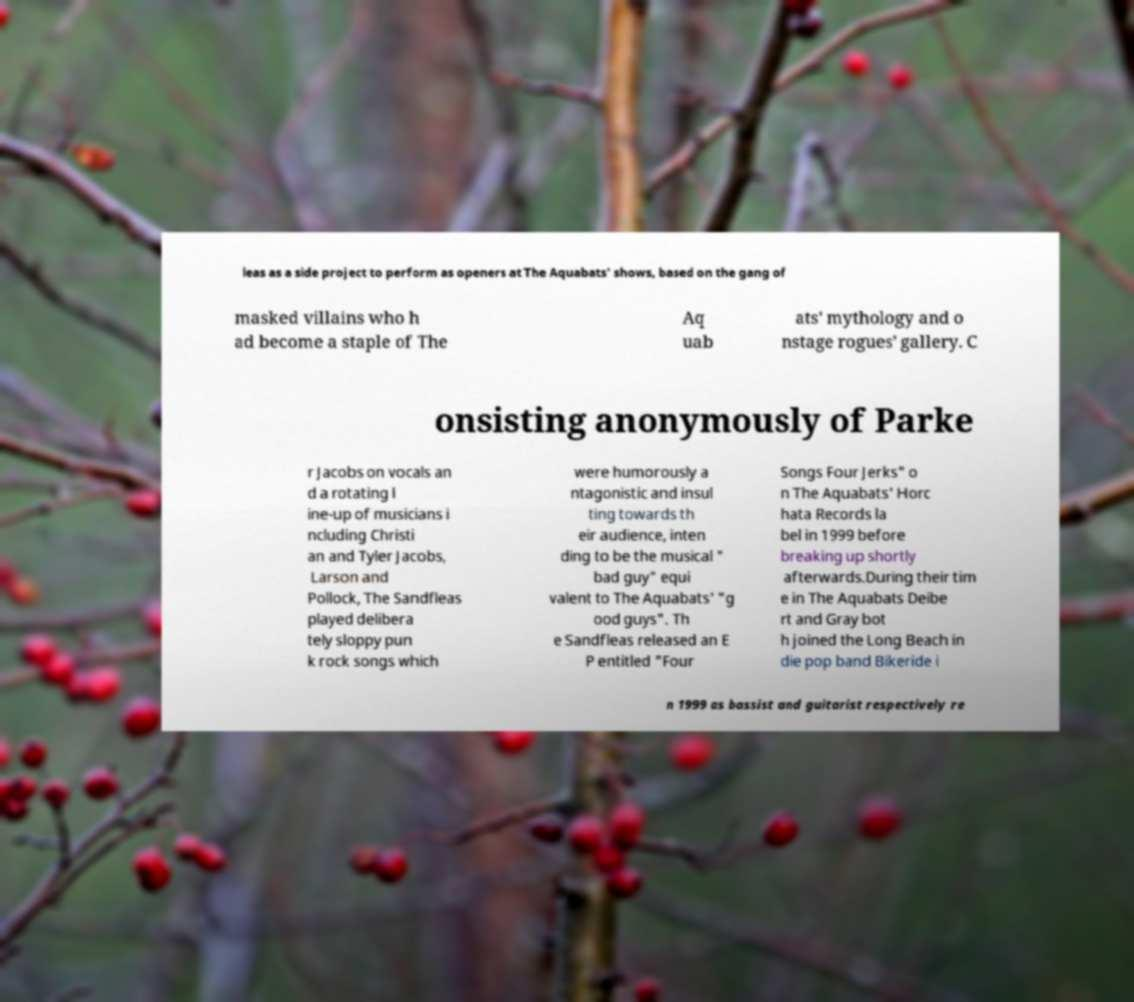For documentation purposes, I need the text within this image transcribed. Could you provide that? leas as a side project to perform as openers at The Aquabats' shows, based on the gang of masked villains who h ad become a staple of The Aq uab ats' mythology and o nstage rogues' gallery. C onsisting anonymously of Parke r Jacobs on vocals an d a rotating l ine-up of musicians i ncluding Christi an and Tyler Jacobs, Larson and Pollock, The Sandfleas played delibera tely sloppy pun k rock songs which were humorously a ntagonistic and insul ting towards th eir audience, inten ding to be the musical " bad guy" equi valent to The Aquabats' "g ood guys". Th e Sandfleas released an E P entitled "Four Songs Four Jerks" o n The Aquabats' Horc hata Records la bel in 1999 before breaking up shortly afterwards.During their tim e in The Aquabats Deibe rt and Gray bot h joined the Long Beach in die pop band Bikeride i n 1999 as bassist and guitarist respectively re 